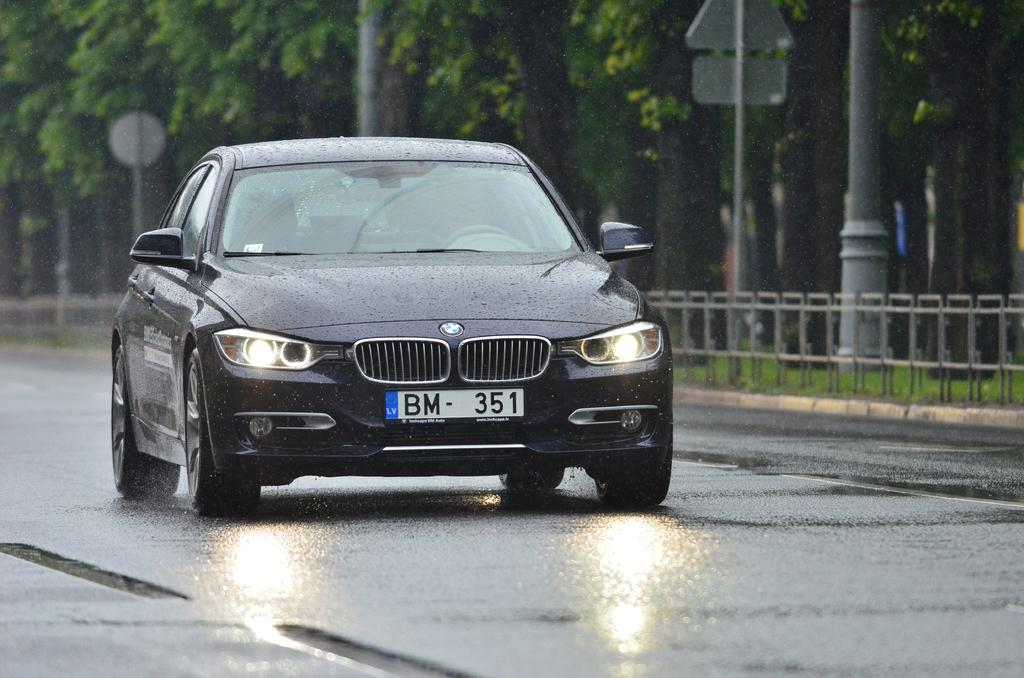What is happening on the road in the image? There is a car passing on the road in the image. What is located on the other side of the road? There is a metal fence on the other side of the road. What can be seen beyond the metal fence? There are sign boards, lamp posts, and trees on the other side of the metal fence. What type of wire is being used to hold the pocket in the image? There is no pocket or wire present in the image. What kind of vessel is being carried by the car in the image? There is no vessel being carried by the car in the image; it is simply passing on the road. 